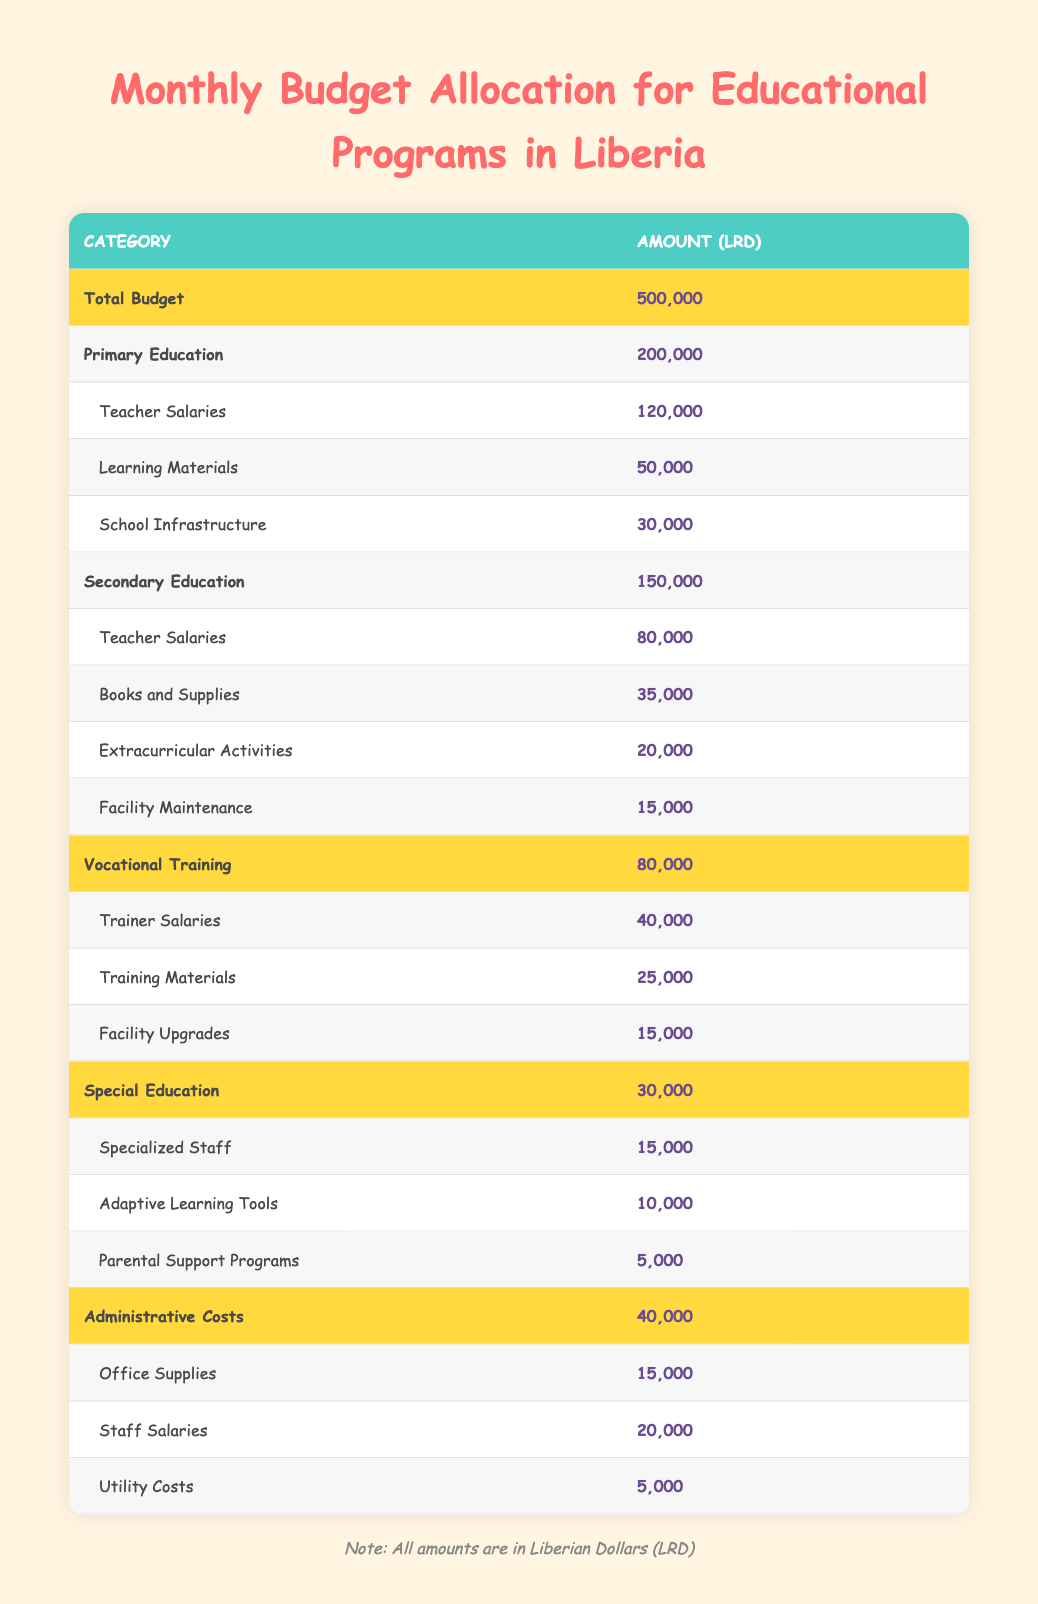What is the allocated amount for Primary Education? The table lists the allocated amount for Primary Education under the section "Primary Education" as 200,000 LRD.
Answer: 200,000 LRD What is the total allocated amount for Secondary Education and Vocational Training combined? The allocated amounts for Secondary Education and Vocational Training are 150,000 LRD and 80,000 LRD respectively. Combining these, we get 150,000 + 80,000 = 230,000 LRD.
Answer: 230,000 LRD Is the amount allocated for Administrative Costs greater than that for Special Education? The allocated amount for Administrative Costs is 40,000 LRD, while for Special Education, it is 30,000 LRD. Since 40,000 is greater than 30,000, the statement is true.
Answer: Yes What percentage of the total budget is allocated to Primary Education? The total budget is 500,000 LRD and the allocated amount for Primary Education is 200,000 LRD. To find the percentage, you calculate (200,000 / 500,000) * 100, which equals 40%.
Answer: 40% What is the total allocated amount for Learning Materials, Books and Supplies, and Training Materials? The amounts for these categories are 50,000 LRD (Learning Materials), 35,000 LRD (Books and Supplies), and 25,000 LRD (Training Materials). Adding these gives 50,000 + 35,000 + 25,000 = 110,000 LRD.
Answer: 110,000 LRD What is the difference in allocated amounts between Teacher Salaries for Primary Education and Secondary Education? The Teacher Salaries for Primary Education is 120,000 LRD, while for Secondary Education, it is 80,000 LRD. The difference is calculated as 120,000 - 80,000 = 40,000 LRD.
Answer: 40,000 LRD Are the allocated amounts for Vocational Training and Special Education equal? The allocated amount for Vocational Training is 80,000 LRD and for Special Education is 30,000 LRD. Since these amounts are not equal, the statement is false.
Answer: No If all amounts for Teacher Salaries, Trainer Salaries, and Specialized Staff are summed, what is the total? The amounts are 120,000 LRD (Teacher Salaries for Primary Education), 80,000 LRD (Teacher Salaries for Secondary Education), and 15,000 LRD (Specialized Staff for Special Education). Adding these gives 120,000 + 80,000 + 15,000 = 215,000 LRD.
Answer: 215,000 LRD 